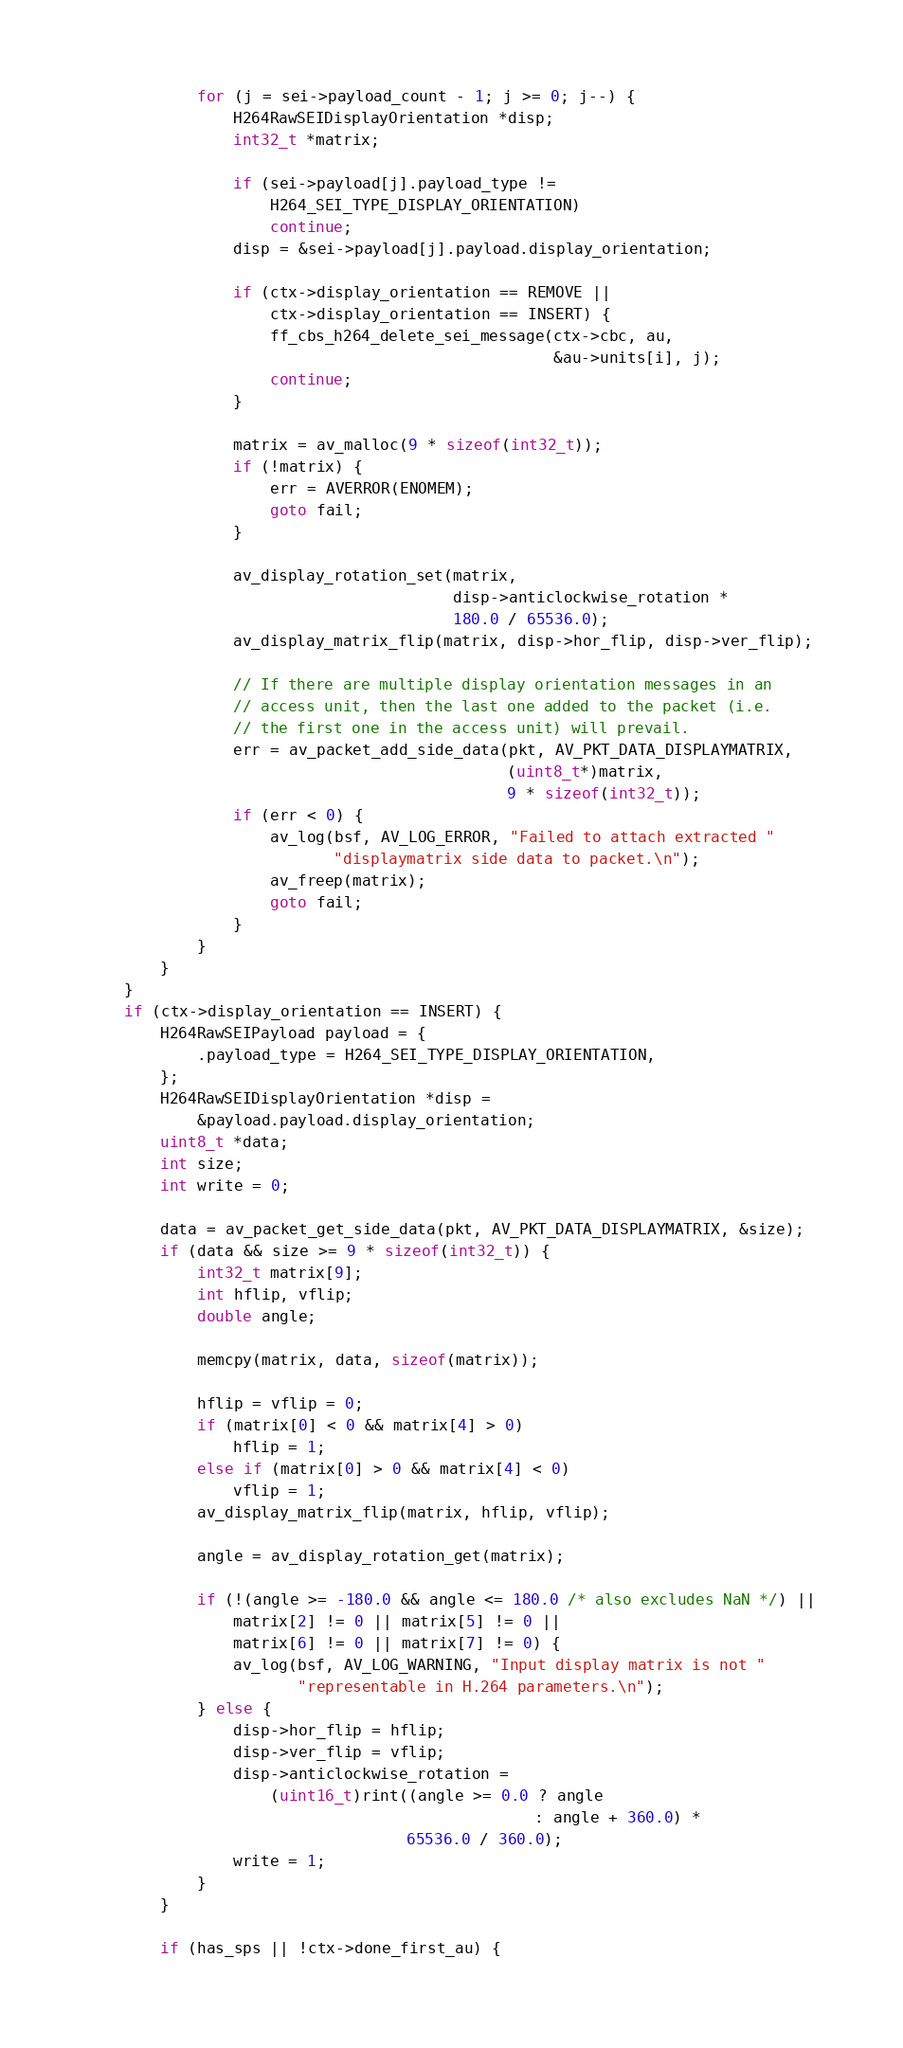Convert code to text. <code><loc_0><loc_0><loc_500><loc_500><_C_>            for (j = sei->payload_count - 1; j >= 0; j--) {
                H264RawSEIDisplayOrientation *disp;
                int32_t *matrix;

                if (sei->payload[j].payload_type !=
                    H264_SEI_TYPE_DISPLAY_ORIENTATION)
                    continue;
                disp = &sei->payload[j].payload.display_orientation;

                if (ctx->display_orientation == REMOVE ||
                    ctx->display_orientation == INSERT) {
                    ff_cbs_h264_delete_sei_message(ctx->cbc, au,
                                                   &au->units[i], j);
                    continue;
                }

                matrix = av_malloc(9 * sizeof(int32_t));
                if (!matrix) {
                    err = AVERROR(ENOMEM);
                    goto fail;
                }

                av_display_rotation_set(matrix,
                                        disp->anticlockwise_rotation *
                                        180.0 / 65536.0);
                av_display_matrix_flip(matrix, disp->hor_flip, disp->ver_flip);

                // If there are multiple display orientation messages in an
                // access unit, then the last one added to the packet (i.e.
                // the first one in the access unit) will prevail.
                err = av_packet_add_side_data(pkt, AV_PKT_DATA_DISPLAYMATRIX,
                                              (uint8_t*)matrix,
                                              9 * sizeof(int32_t));
                if (err < 0) {
                    av_log(bsf, AV_LOG_ERROR, "Failed to attach extracted "
                           "displaymatrix side data to packet.\n");
                    av_freep(matrix);
                    goto fail;
                }
            }
        }
    }
    if (ctx->display_orientation == INSERT) {
        H264RawSEIPayload payload = {
            .payload_type = H264_SEI_TYPE_DISPLAY_ORIENTATION,
        };
        H264RawSEIDisplayOrientation *disp =
            &payload.payload.display_orientation;
        uint8_t *data;
        int size;
        int write = 0;

        data = av_packet_get_side_data(pkt, AV_PKT_DATA_DISPLAYMATRIX, &size);
        if (data && size >= 9 * sizeof(int32_t)) {
            int32_t matrix[9];
            int hflip, vflip;
            double angle;

            memcpy(matrix, data, sizeof(matrix));

            hflip = vflip = 0;
            if (matrix[0] < 0 && matrix[4] > 0)
                hflip = 1;
            else if (matrix[0] > 0 && matrix[4] < 0)
                vflip = 1;
            av_display_matrix_flip(matrix, hflip, vflip);

            angle = av_display_rotation_get(matrix);

            if (!(angle >= -180.0 && angle <= 180.0 /* also excludes NaN */) ||
                matrix[2] != 0 || matrix[5] != 0 ||
                matrix[6] != 0 || matrix[7] != 0) {
                av_log(bsf, AV_LOG_WARNING, "Input display matrix is not "
                       "representable in H.264 parameters.\n");
            } else {
                disp->hor_flip = hflip;
                disp->ver_flip = vflip;
                disp->anticlockwise_rotation =
                    (uint16_t)rint((angle >= 0.0 ? angle
                                                 : angle + 360.0) *
                                   65536.0 / 360.0);
                write = 1;
            }
        }

        if (has_sps || !ctx->done_first_au) {</code> 